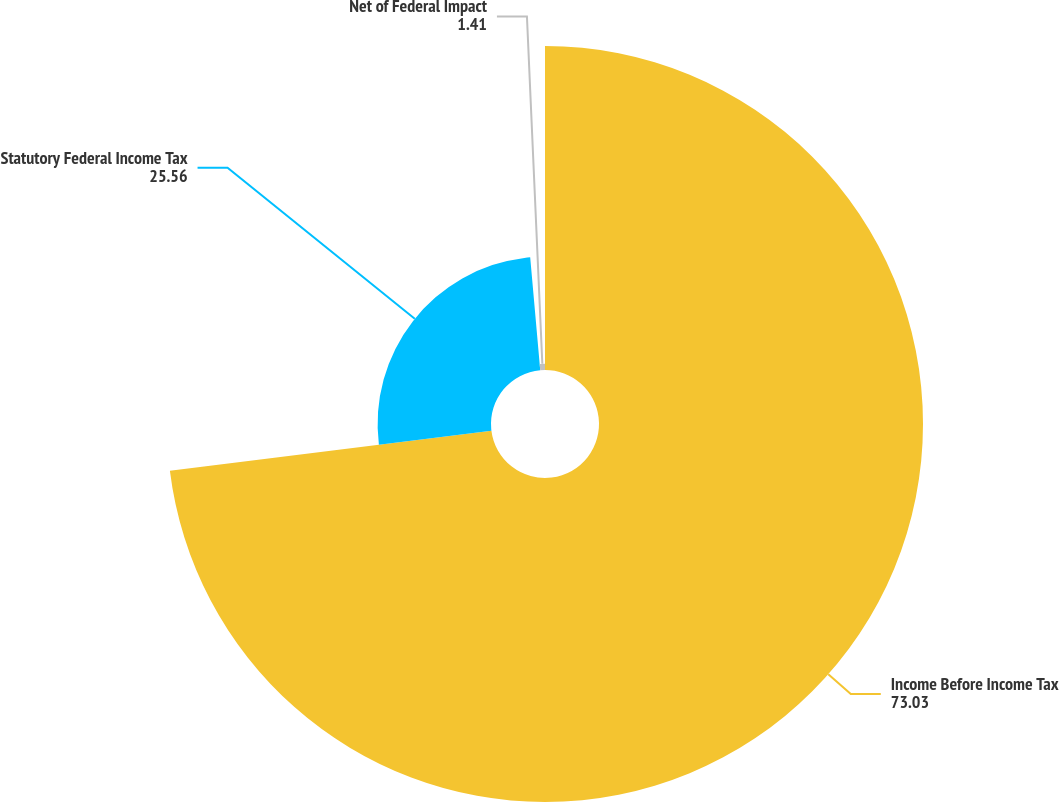Convert chart to OTSL. <chart><loc_0><loc_0><loc_500><loc_500><pie_chart><fcel>Income Before Income Tax<fcel>Statutory Federal Income Tax<fcel>Net of Federal Impact<nl><fcel>73.03%<fcel>25.56%<fcel>1.41%<nl></chart> 